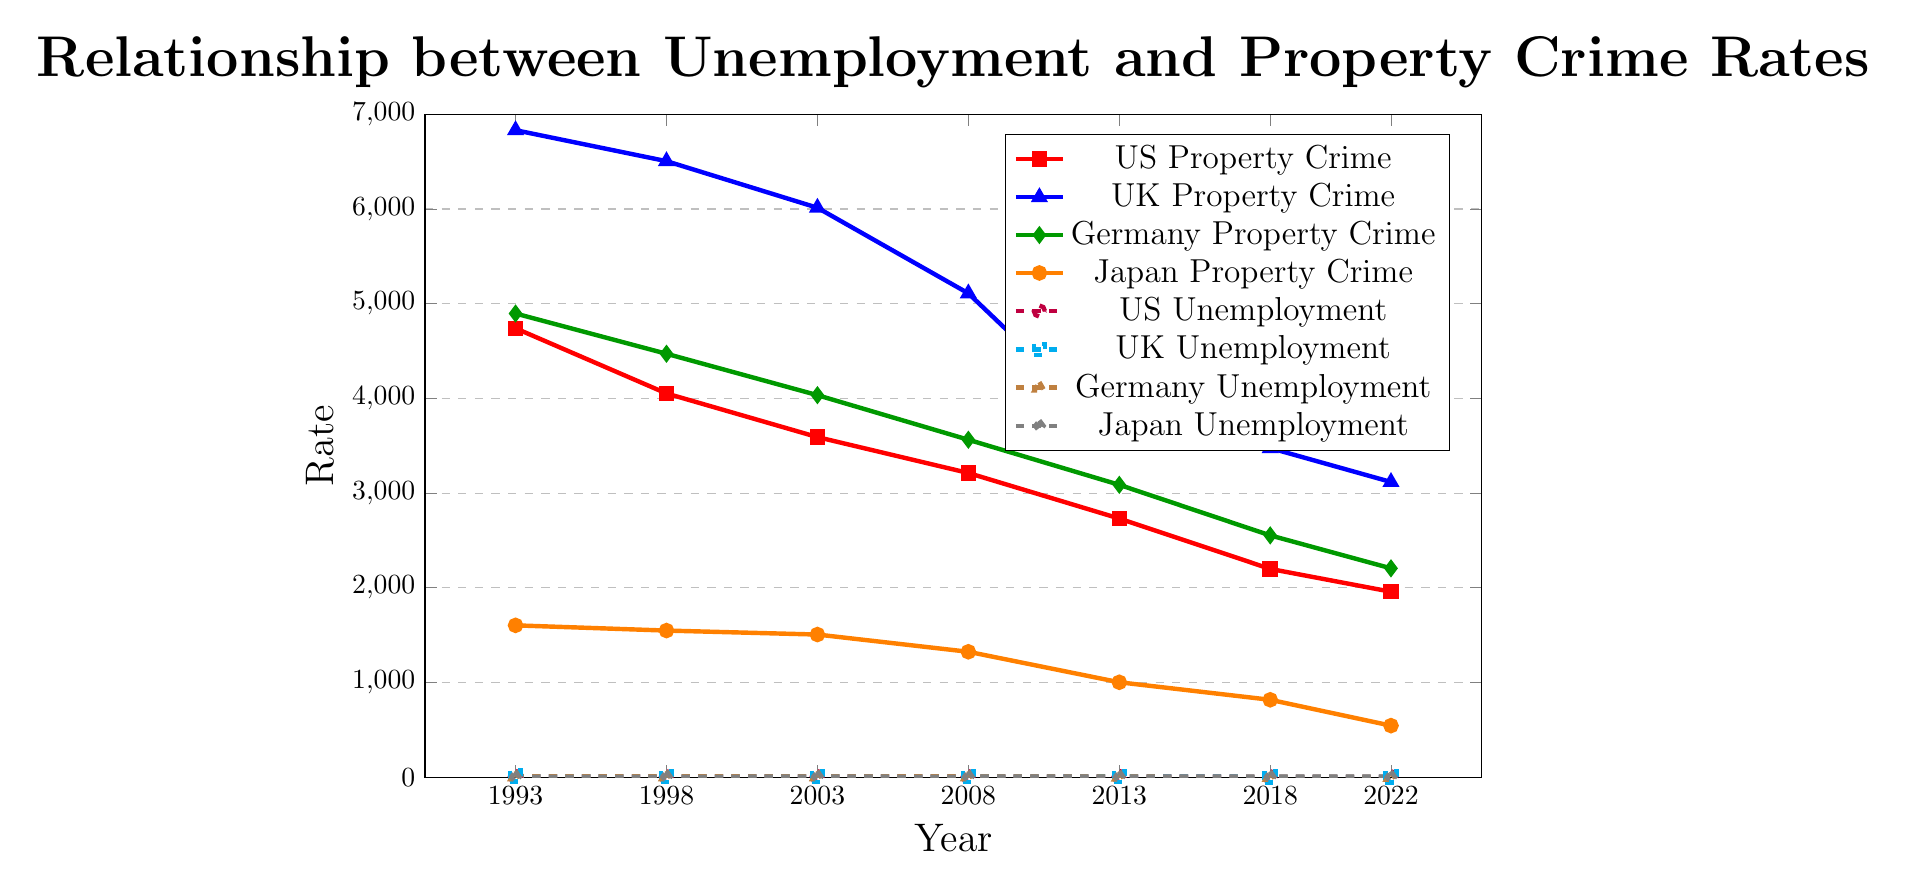How did the property crime rate in the United States change from 1993 to 2013? The property crime rate in the United States in 1993 was 4740, and it decreased to 2731 in 2013. The change over this period is the difference between these two values: 4740 - 2731.
Answer: 2009 Compare the unemployment rates of Germany in 1998 and 2022. Which year had a higher rate? The unemployment rate in Germany in 1998 was 9.2, while in 2022 it was 3.0. Comparing these two values, 9.2 is greater than 3.0, indicating that 1998 had a higher unemployment rate.
Answer: 1998 Which country had the lowest property crime rate in 2022? In 2022, the property crime rates were: US (1958), UK (3117), Germany (2205), and Japan (544). Comparing these values, Japan had the lowest property crime rate of 544.
Answer: Japan What is the average property crime rate in the UK from 1993 to 2022? The property crime rates in the UK from 1993 to 2022 were: 6832, 6505, 6013, 5109, 3588, 3475, and 3117. Summing these values gives 34639. Dividing this sum by the number of years (7) provides the average: 34639 / 7.
Answer: 4948.428571 In which year was the gap between the property crime rate and unemployment rate the smallest in Japan? The differences between the property crime rate and unemployment rate each year in Japan are: 
1993: 1603 - 2.5 = 1600.5,
1998: 1548 - 4.1 = 1543.9,
2003: 1506 - 5.3 = 1500.7,
2008: 1324 - 4.0 = 1320,
2013: 1002 - 4.0 = 998,
2018: 817 - 2.4 = 814.6,
2022: 544 - 2.6 = 541.4.
The smallest gap is in 2022.
Answer: 2022 